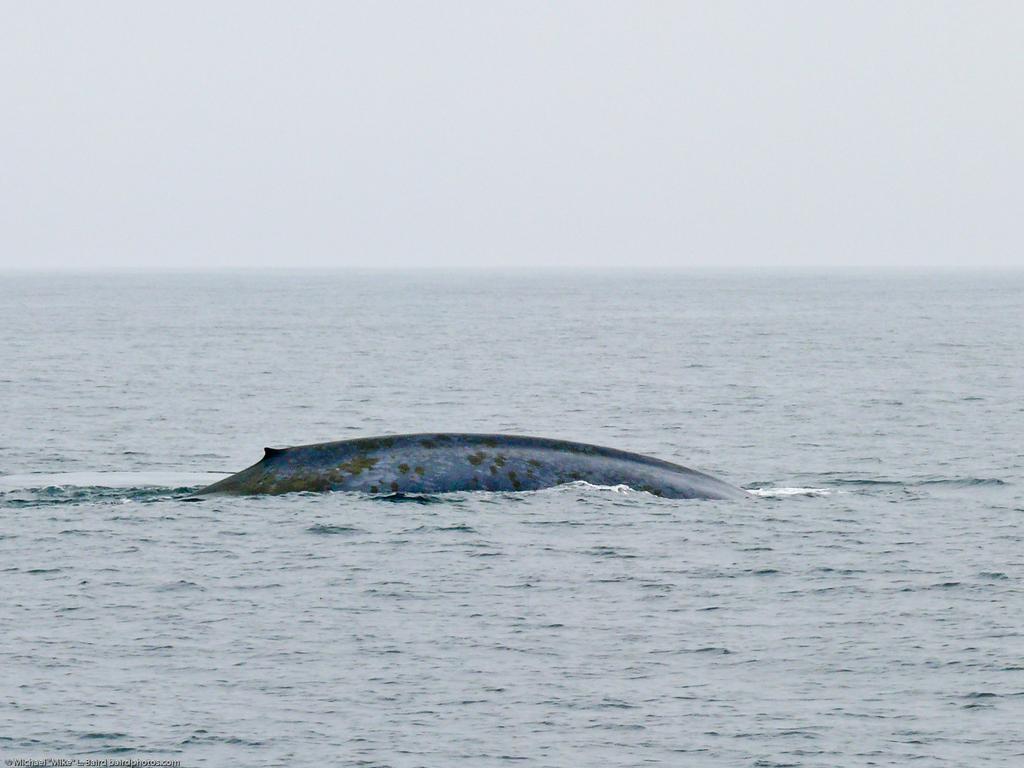Can you describe this image briefly? This image is clicked near the ocean. At the bottom, there is water. In the middle, it looks like a whale. At the top, there is sky. 